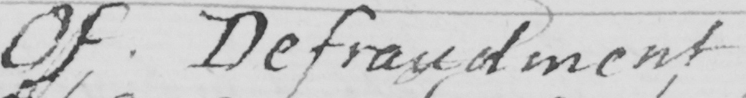What text is written in this handwritten line? Of Defraudment 